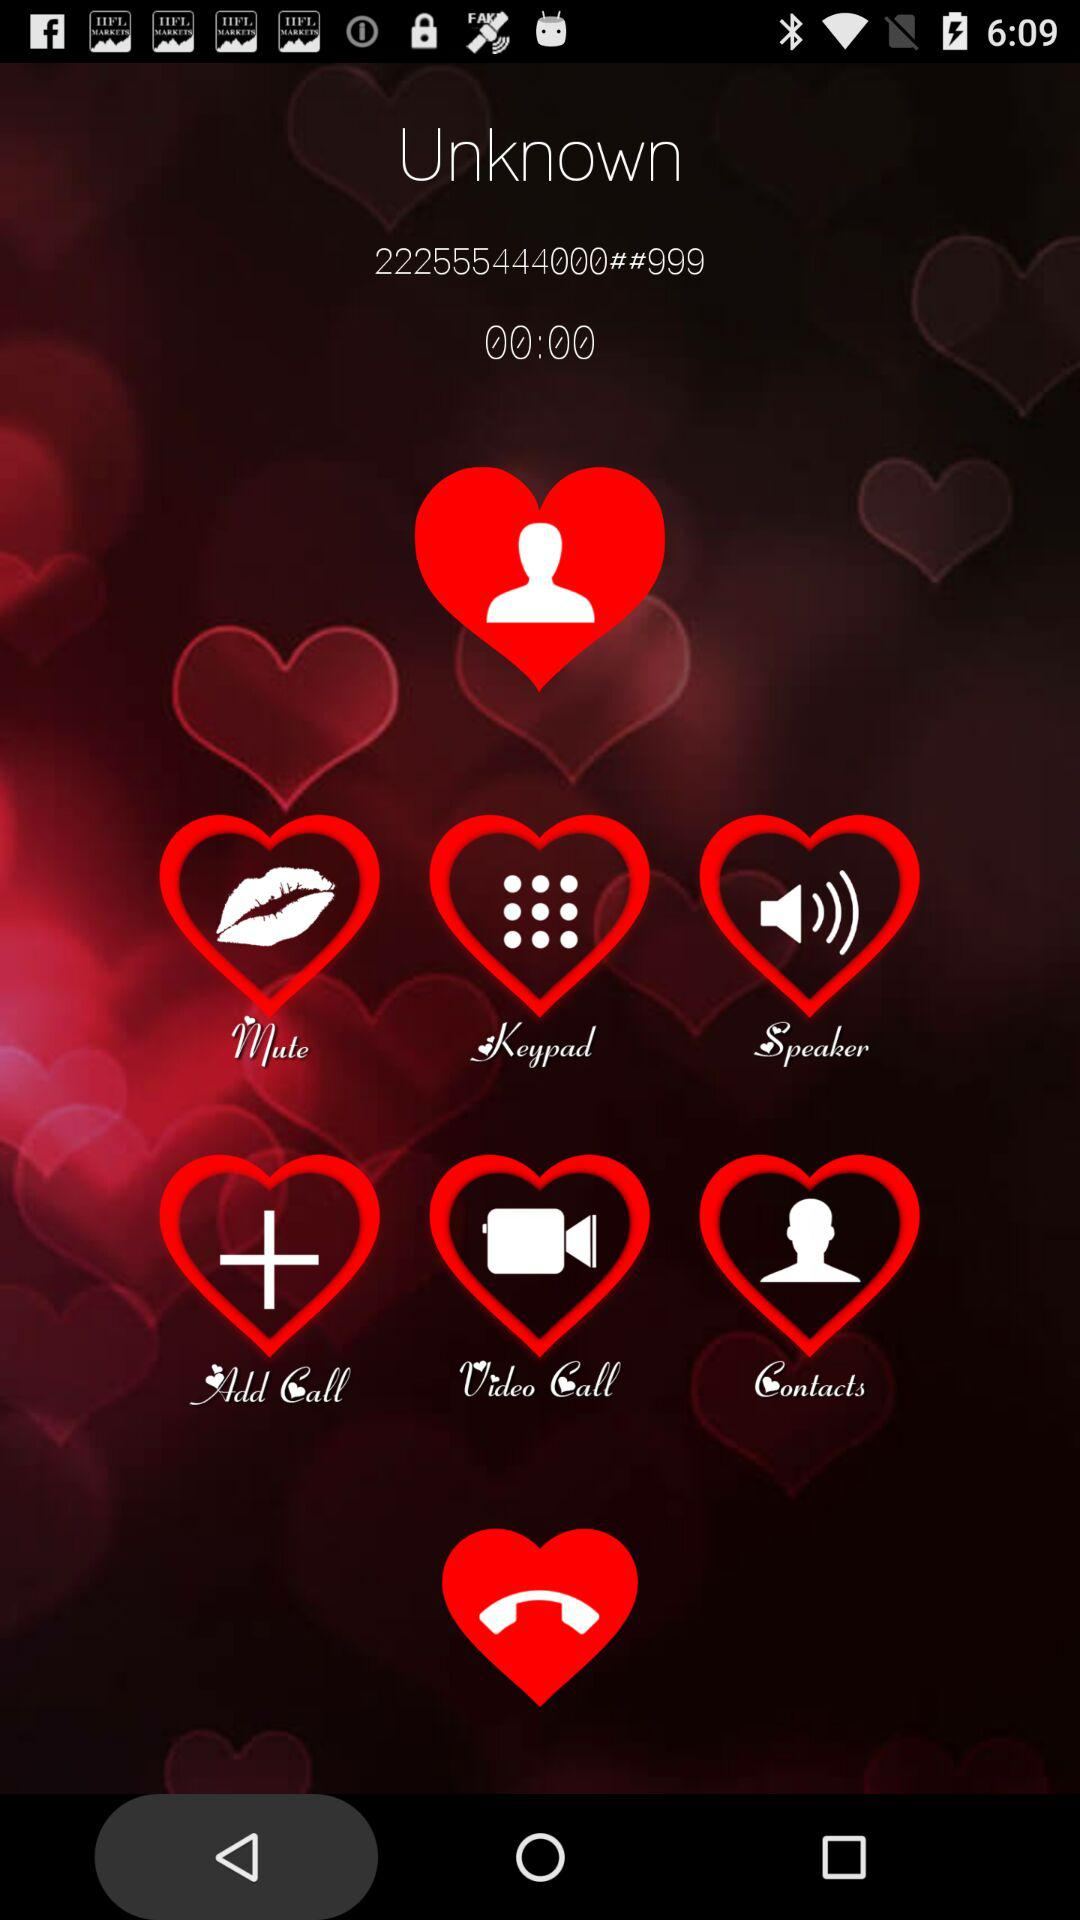What is the call duration? The call duration is 0:00. 